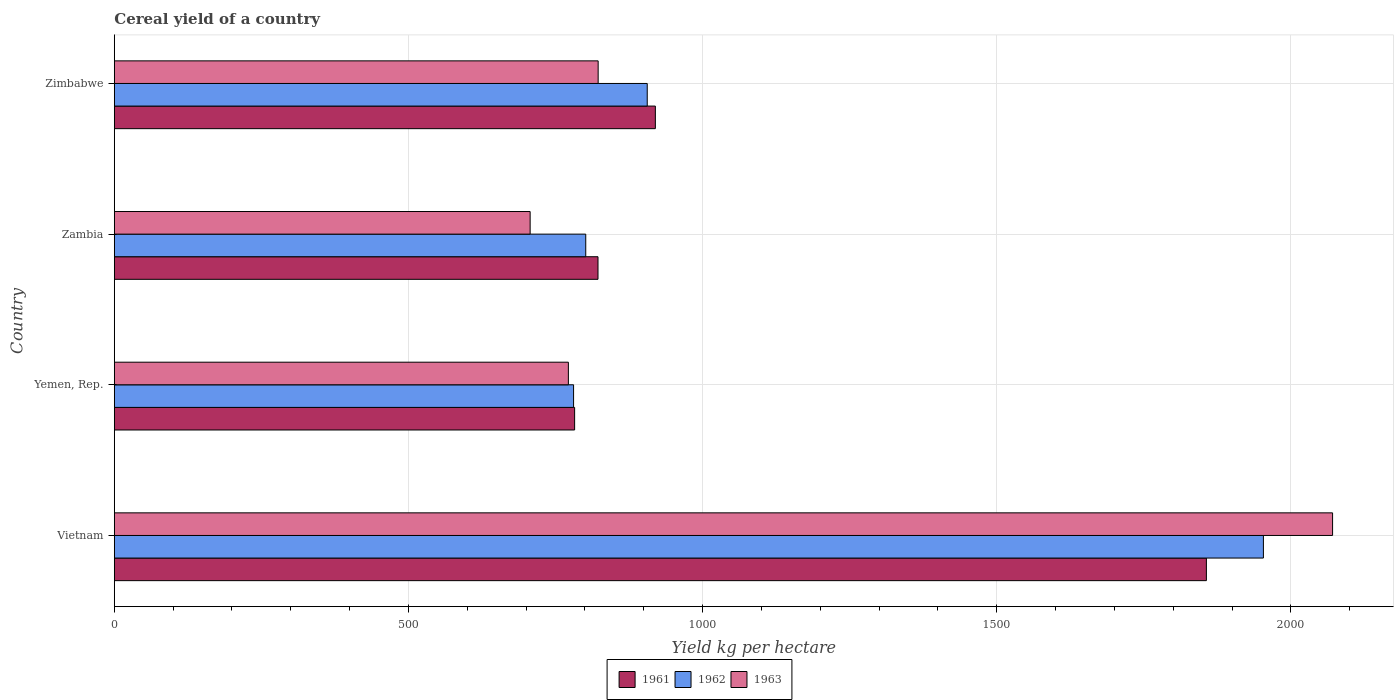How many different coloured bars are there?
Offer a terse response. 3. Are the number of bars on each tick of the Y-axis equal?
Your answer should be very brief. Yes. How many bars are there on the 3rd tick from the top?
Give a very brief answer. 3. How many bars are there on the 1st tick from the bottom?
Provide a short and direct response. 3. What is the label of the 3rd group of bars from the top?
Make the answer very short. Yemen, Rep. What is the total cereal yield in 1963 in Yemen, Rep.?
Give a very brief answer. 771.85. Across all countries, what is the maximum total cereal yield in 1963?
Offer a terse response. 2070.86. Across all countries, what is the minimum total cereal yield in 1961?
Your answer should be very brief. 782.47. In which country was the total cereal yield in 1961 maximum?
Offer a terse response. Vietnam. In which country was the total cereal yield in 1962 minimum?
Make the answer very short. Yemen, Rep. What is the total total cereal yield in 1962 in the graph?
Provide a succinct answer. 4441.23. What is the difference between the total cereal yield in 1963 in Vietnam and that in Yemen, Rep.?
Provide a short and direct response. 1299.01. What is the difference between the total cereal yield in 1963 in Yemen, Rep. and the total cereal yield in 1961 in Zambia?
Offer a very short reply. -50.36. What is the average total cereal yield in 1963 per country?
Keep it short and to the point. 1093.01. What is the difference between the total cereal yield in 1961 and total cereal yield in 1963 in Vietnam?
Provide a succinct answer. -214.5. What is the ratio of the total cereal yield in 1963 in Vietnam to that in Zimbabwe?
Provide a short and direct response. 2.52. Is the total cereal yield in 1962 in Zambia less than that in Zimbabwe?
Your answer should be compact. Yes. Is the difference between the total cereal yield in 1961 in Vietnam and Yemen, Rep. greater than the difference between the total cereal yield in 1963 in Vietnam and Yemen, Rep.?
Keep it short and to the point. No. What is the difference between the highest and the second highest total cereal yield in 1963?
Offer a terse response. 1248.39. What is the difference between the highest and the lowest total cereal yield in 1962?
Keep it short and to the point. 1172.6. In how many countries, is the total cereal yield in 1963 greater than the average total cereal yield in 1963 taken over all countries?
Ensure brevity in your answer.  1. What does the 2nd bar from the top in Zambia represents?
Provide a short and direct response. 1962. What does the 1st bar from the bottom in Vietnam represents?
Offer a terse response. 1961. How many bars are there?
Make the answer very short. 12. Are the values on the major ticks of X-axis written in scientific E-notation?
Your answer should be compact. No. What is the title of the graph?
Your answer should be compact. Cereal yield of a country. What is the label or title of the X-axis?
Offer a terse response. Yield kg per hectare. What is the label or title of the Y-axis?
Your answer should be compact. Country. What is the Yield kg per hectare in 1961 in Vietnam?
Your answer should be very brief. 1856.36. What is the Yield kg per hectare of 1962 in Vietnam?
Give a very brief answer. 1953.28. What is the Yield kg per hectare in 1963 in Vietnam?
Your response must be concise. 2070.86. What is the Yield kg per hectare in 1961 in Yemen, Rep.?
Make the answer very short. 782.47. What is the Yield kg per hectare in 1962 in Yemen, Rep.?
Give a very brief answer. 780.68. What is the Yield kg per hectare of 1963 in Yemen, Rep.?
Your answer should be very brief. 771.85. What is the Yield kg per hectare of 1961 in Zambia?
Offer a terse response. 822.21. What is the Yield kg per hectare in 1962 in Zambia?
Your response must be concise. 801.38. What is the Yield kg per hectare of 1963 in Zambia?
Offer a terse response. 706.86. What is the Yield kg per hectare in 1961 in Zimbabwe?
Offer a very short reply. 919.71. What is the Yield kg per hectare of 1962 in Zimbabwe?
Your answer should be compact. 905.89. What is the Yield kg per hectare of 1963 in Zimbabwe?
Give a very brief answer. 822.48. Across all countries, what is the maximum Yield kg per hectare of 1961?
Provide a short and direct response. 1856.36. Across all countries, what is the maximum Yield kg per hectare in 1962?
Offer a terse response. 1953.28. Across all countries, what is the maximum Yield kg per hectare in 1963?
Ensure brevity in your answer.  2070.86. Across all countries, what is the minimum Yield kg per hectare of 1961?
Offer a very short reply. 782.47. Across all countries, what is the minimum Yield kg per hectare of 1962?
Keep it short and to the point. 780.68. Across all countries, what is the minimum Yield kg per hectare of 1963?
Give a very brief answer. 706.86. What is the total Yield kg per hectare in 1961 in the graph?
Offer a terse response. 4380.75. What is the total Yield kg per hectare in 1962 in the graph?
Make the answer very short. 4441.23. What is the total Yield kg per hectare in 1963 in the graph?
Your answer should be very brief. 4372.05. What is the difference between the Yield kg per hectare in 1961 in Vietnam and that in Yemen, Rep.?
Keep it short and to the point. 1073.89. What is the difference between the Yield kg per hectare in 1962 in Vietnam and that in Yemen, Rep.?
Your response must be concise. 1172.6. What is the difference between the Yield kg per hectare of 1963 in Vietnam and that in Yemen, Rep.?
Make the answer very short. 1299.01. What is the difference between the Yield kg per hectare of 1961 in Vietnam and that in Zambia?
Your response must be concise. 1034.15. What is the difference between the Yield kg per hectare of 1962 in Vietnam and that in Zambia?
Offer a terse response. 1151.9. What is the difference between the Yield kg per hectare in 1963 in Vietnam and that in Zambia?
Provide a succinct answer. 1364. What is the difference between the Yield kg per hectare of 1961 in Vietnam and that in Zimbabwe?
Offer a terse response. 936.65. What is the difference between the Yield kg per hectare in 1962 in Vietnam and that in Zimbabwe?
Keep it short and to the point. 1047.39. What is the difference between the Yield kg per hectare in 1963 in Vietnam and that in Zimbabwe?
Ensure brevity in your answer.  1248.39. What is the difference between the Yield kg per hectare of 1961 in Yemen, Rep. and that in Zambia?
Your answer should be compact. -39.73. What is the difference between the Yield kg per hectare in 1962 in Yemen, Rep. and that in Zambia?
Make the answer very short. -20.7. What is the difference between the Yield kg per hectare of 1963 in Yemen, Rep. and that in Zambia?
Make the answer very short. 64.99. What is the difference between the Yield kg per hectare in 1961 in Yemen, Rep. and that in Zimbabwe?
Your response must be concise. -137.24. What is the difference between the Yield kg per hectare in 1962 in Yemen, Rep. and that in Zimbabwe?
Provide a succinct answer. -125.21. What is the difference between the Yield kg per hectare in 1963 in Yemen, Rep. and that in Zimbabwe?
Your answer should be very brief. -50.63. What is the difference between the Yield kg per hectare of 1961 in Zambia and that in Zimbabwe?
Offer a terse response. -97.5. What is the difference between the Yield kg per hectare in 1962 in Zambia and that in Zimbabwe?
Make the answer very short. -104.51. What is the difference between the Yield kg per hectare in 1963 in Zambia and that in Zimbabwe?
Offer a terse response. -115.62. What is the difference between the Yield kg per hectare in 1961 in Vietnam and the Yield kg per hectare in 1962 in Yemen, Rep.?
Your response must be concise. 1075.68. What is the difference between the Yield kg per hectare in 1961 in Vietnam and the Yield kg per hectare in 1963 in Yemen, Rep.?
Give a very brief answer. 1084.51. What is the difference between the Yield kg per hectare of 1962 in Vietnam and the Yield kg per hectare of 1963 in Yemen, Rep.?
Make the answer very short. 1181.43. What is the difference between the Yield kg per hectare in 1961 in Vietnam and the Yield kg per hectare in 1962 in Zambia?
Provide a short and direct response. 1054.98. What is the difference between the Yield kg per hectare in 1961 in Vietnam and the Yield kg per hectare in 1963 in Zambia?
Offer a very short reply. 1149.5. What is the difference between the Yield kg per hectare in 1962 in Vietnam and the Yield kg per hectare in 1963 in Zambia?
Your response must be concise. 1246.42. What is the difference between the Yield kg per hectare of 1961 in Vietnam and the Yield kg per hectare of 1962 in Zimbabwe?
Your answer should be compact. 950.47. What is the difference between the Yield kg per hectare in 1961 in Vietnam and the Yield kg per hectare in 1963 in Zimbabwe?
Your answer should be very brief. 1033.88. What is the difference between the Yield kg per hectare in 1962 in Vietnam and the Yield kg per hectare in 1963 in Zimbabwe?
Keep it short and to the point. 1130.81. What is the difference between the Yield kg per hectare in 1961 in Yemen, Rep. and the Yield kg per hectare in 1962 in Zambia?
Keep it short and to the point. -18.91. What is the difference between the Yield kg per hectare in 1961 in Yemen, Rep. and the Yield kg per hectare in 1963 in Zambia?
Your response must be concise. 75.61. What is the difference between the Yield kg per hectare of 1962 in Yemen, Rep. and the Yield kg per hectare of 1963 in Zambia?
Ensure brevity in your answer.  73.82. What is the difference between the Yield kg per hectare of 1961 in Yemen, Rep. and the Yield kg per hectare of 1962 in Zimbabwe?
Your answer should be compact. -123.42. What is the difference between the Yield kg per hectare of 1961 in Yemen, Rep. and the Yield kg per hectare of 1963 in Zimbabwe?
Ensure brevity in your answer.  -40.01. What is the difference between the Yield kg per hectare of 1962 in Yemen, Rep. and the Yield kg per hectare of 1963 in Zimbabwe?
Ensure brevity in your answer.  -41.8. What is the difference between the Yield kg per hectare of 1961 in Zambia and the Yield kg per hectare of 1962 in Zimbabwe?
Ensure brevity in your answer.  -83.68. What is the difference between the Yield kg per hectare of 1961 in Zambia and the Yield kg per hectare of 1963 in Zimbabwe?
Your answer should be compact. -0.27. What is the difference between the Yield kg per hectare in 1962 in Zambia and the Yield kg per hectare in 1963 in Zimbabwe?
Offer a very short reply. -21.09. What is the average Yield kg per hectare in 1961 per country?
Your response must be concise. 1095.19. What is the average Yield kg per hectare of 1962 per country?
Your answer should be very brief. 1110.31. What is the average Yield kg per hectare in 1963 per country?
Provide a succinct answer. 1093.01. What is the difference between the Yield kg per hectare of 1961 and Yield kg per hectare of 1962 in Vietnam?
Your answer should be compact. -96.92. What is the difference between the Yield kg per hectare in 1961 and Yield kg per hectare in 1963 in Vietnam?
Offer a very short reply. -214.5. What is the difference between the Yield kg per hectare of 1962 and Yield kg per hectare of 1963 in Vietnam?
Provide a succinct answer. -117.58. What is the difference between the Yield kg per hectare in 1961 and Yield kg per hectare in 1962 in Yemen, Rep.?
Provide a succinct answer. 1.79. What is the difference between the Yield kg per hectare in 1961 and Yield kg per hectare in 1963 in Yemen, Rep.?
Ensure brevity in your answer.  10.62. What is the difference between the Yield kg per hectare of 1962 and Yield kg per hectare of 1963 in Yemen, Rep.?
Provide a succinct answer. 8.83. What is the difference between the Yield kg per hectare of 1961 and Yield kg per hectare of 1962 in Zambia?
Offer a terse response. 20.82. What is the difference between the Yield kg per hectare in 1961 and Yield kg per hectare in 1963 in Zambia?
Give a very brief answer. 115.35. What is the difference between the Yield kg per hectare of 1962 and Yield kg per hectare of 1963 in Zambia?
Provide a short and direct response. 94.52. What is the difference between the Yield kg per hectare of 1961 and Yield kg per hectare of 1962 in Zimbabwe?
Offer a very short reply. 13.82. What is the difference between the Yield kg per hectare in 1961 and Yield kg per hectare in 1963 in Zimbabwe?
Offer a very short reply. 97.23. What is the difference between the Yield kg per hectare in 1962 and Yield kg per hectare in 1963 in Zimbabwe?
Give a very brief answer. 83.41. What is the ratio of the Yield kg per hectare of 1961 in Vietnam to that in Yemen, Rep.?
Offer a very short reply. 2.37. What is the ratio of the Yield kg per hectare of 1962 in Vietnam to that in Yemen, Rep.?
Provide a succinct answer. 2.5. What is the ratio of the Yield kg per hectare of 1963 in Vietnam to that in Yemen, Rep.?
Ensure brevity in your answer.  2.68. What is the ratio of the Yield kg per hectare in 1961 in Vietnam to that in Zambia?
Provide a succinct answer. 2.26. What is the ratio of the Yield kg per hectare of 1962 in Vietnam to that in Zambia?
Ensure brevity in your answer.  2.44. What is the ratio of the Yield kg per hectare in 1963 in Vietnam to that in Zambia?
Your answer should be very brief. 2.93. What is the ratio of the Yield kg per hectare of 1961 in Vietnam to that in Zimbabwe?
Make the answer very short. 2.02. What is the ratio of the Yield kg per hectare in 1962 in Vietnam to that in Zimbabwe?
Ensure brevity in your answer.  2.16. What is the ratio of the Yield kg per hectare of 1963 in Vietnam to that in Zimbabwe?
Your answer should be compact. 2.52. What is the ratio of the Yield kg per hectare in 1961 in Yemen, Rep. to that in Zambia?
Your response must be concise. 0.95. What is the ratio of the Yield kg per hectare in 1962 in Yemen, Rep. to that in Zambia?
Provide a short and direct response. 0.97. What is the ratio of the Yield kg per hectare of 1963 in Yemen, Rep. to that in Zambia?
Ensure brevity in your answer.  1.09. What is the ratio of the Yield kg per hectare in 1961 in Yemen, Rep. to that in Zimbabwe?
Your response must be concise. 0.85. What is the ratio of the Yield kg per hectare in 1962 in Yemen, Rep. to that in Zimbabwe?
Your answer should be very brief. 0.86. What is the ratio of the Yield kg per hectare in 1963 in Yemen, Rep. to that in Zimbabwe?
Your answer should be very brief. 0.94. What is the ratio of the Yield kg per hectare of 1961 in Zambia to that in Zimbabwe?
Ensure brevity in your answer.  0.89. What is the ratio of the Yield kg per hectare in 1962 in Zambia to that in Zimbabwe?
Offer a very short reply. 0.88. What is the ratio of the Yield kg per hectare of 1963 in Zambia to that in Zimbabwe?
Give a very brief answer. 0.86. What is the difference between the highest and the second highest Yield kg per hectare in 1961?
Your answer should be compact. 936.65. What is the difference between the highest and the second highest Yield kg per hectare of 1962?
Provide a short and direct response. 1047.39. What is the difference between the highest and the second highest Yield kg per hectare of 1963?
Make the answer very short. 1248.39. What is the difference between the highest and the lowest Yield kg per hectare in 1961?
Make the answer very short. 1073.89. What is the difference between the highest and the lowest Yield kg per hectare of 1962?
Your response must be concise. 1172.6. What is the difference between the highest and the lowest Yield kg per hectare in 1963?
Provide a succinct answer. 1364. 